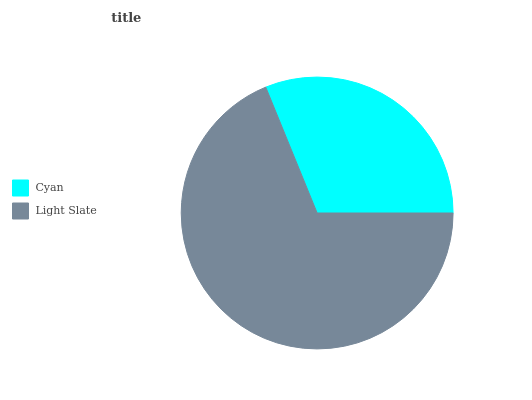Is Cyan the minimum?
Answer yes or no. Yes. Is Light Slate the maximum?
Answer yes or no. Yes. Is Light Slate the minimum?
Answer yes or no. No. Is Light Slate greater than Cyan?
Answer yes or no. Yes. Is Cyan less than Light Slate?
Answer yes or no. Yes. Is Cyan greater than Light Slate?
Answer yes or no. No. Is Light Slate less than Cyan?
Answer yes or no. No. Is Light Slate the high median?
Answer yes or no. Yes. Is Cyan the low median?
Answer yes or no. Yes. Is Cyan the high median?
Answer yes or no. No. Is Light Slate the low median?
Answer yes or no. No. 